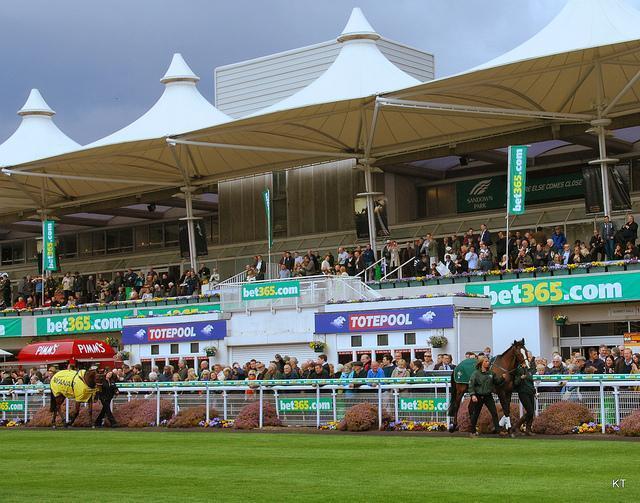How many horses are there?
Give a very brief answer. 2. How many white trucks can you see?
Give a very brief answer. 0. 